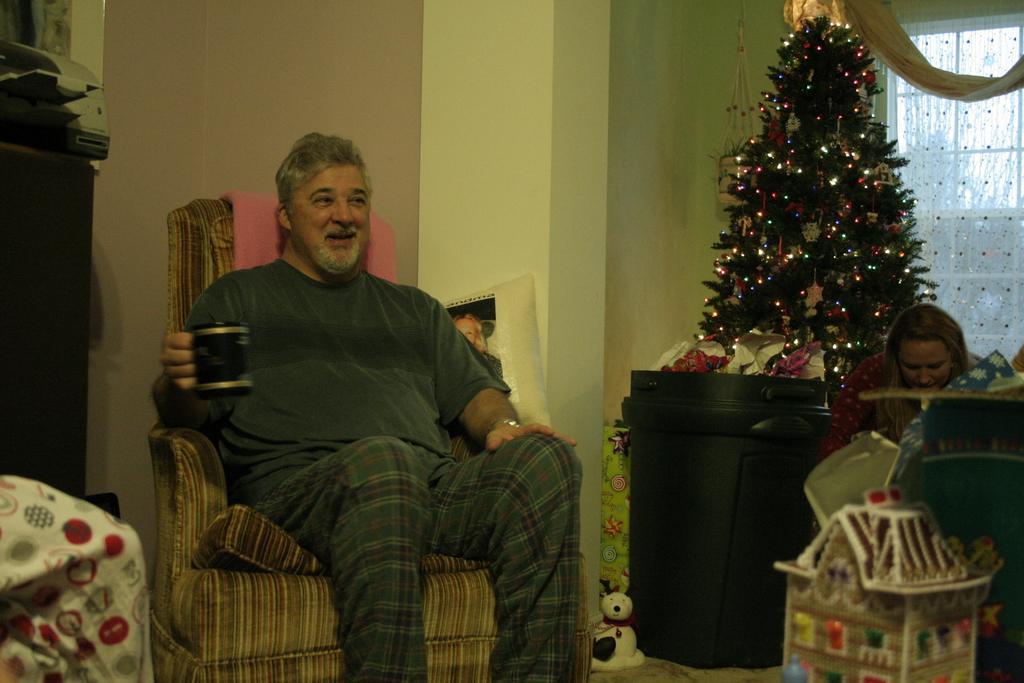How would you summarize this image in a sentence or two? This is the picture of a room. In this image there is a man sitting and smiling and holding the cup. On the right side of the image there is a woman and there is a Christmas tree and there are objects and there is a curtain and window and there is a tree behind the window. On the left side of the image there is an object on the table. At the bottom there is a toy on the floor. 